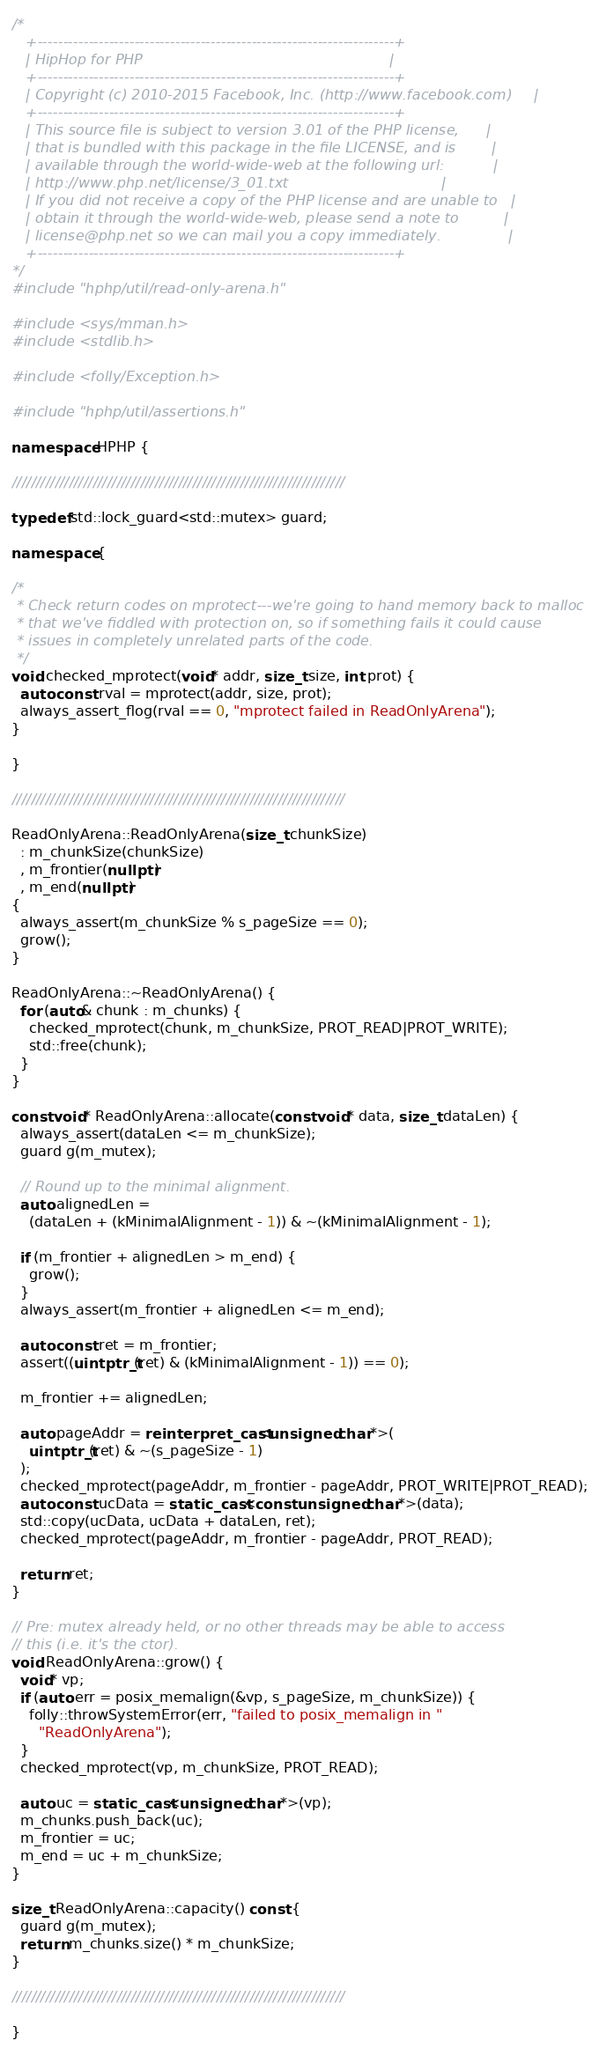<code> <loc_0><loc_0><loc_500><loc_500><_C++_>/*
   +----------------------------------------------------------------------+
   | HipHop for PHP                                                       |
   +----------------------------------------------------------------------+
   | Copyright (c) 2010-2015 Facebook, Inc. (http://www.facebook.com)     |
   +----------------------------------------------------------------------+
   | This source file is subject to version 3.01 of the PHP license,      |
   | that is bundled with this package in the file LICENSE, and is        |
   | available through the world-wide-web at the following url:           |
   | http://www.php.net/license/3_01.txt                                  |
   | If you did not receive a copy of the PHP license and are unable to   |
   | obtain it through the world-wide-web, please send a note to          |
   | license@php.net so we can mail you a copy immediately.               |
   +----------------------------------------------------------------------+
*/
#include "hphp/util/read-only-arena.h"

#include <sys/mman.h>
#include <stdlib.h>

#include <folly/Exception.h>

#include "hphp/util/assertions.h"

namespace HPHP {

//////////////////////////////////////////////////////////////////////

typedef std::lock_guard<std::mutex> guard;

namespace {

/*
 * Check return codes on mprotect---we're going to hand memory back to malloc
 * that we've fiddled with protection on, so if something fails it could cause
 * issues in completely unrelated parts of the code.
 */
void checked_mprotect(void* addr, size_t size, int prot) {
  auto const rval = mprotect(addr, size, prot);
  always_assert_flog(rval == 0, "mprotect failed in ReadOnlyArena");
}

}

//////////////////////////////////////////////////////////////////////

ReadOnlyArena::ReadOnlyArena(size_t chunkSize)
  : m_chunkSize(chunkSize)
  , m_frontier(nullptr)
  , m_end(nullptr)
{
  always_assert(m_chunkSize % s_pageSize == 0);
  grow();
}

ReadOnlyArena::~ReadOnlyArena() {
  for (auto& chunk : m_chunks) {
    checked_mprotect(chunk, m_chunkSize, PROT_READ|PROT_WRITE);
    std::free(chunk);
  }
}

const void* ReadOnlyArena::allocate(const void* data, size_t dataLen) {
  always_assert(dataLen <= m_chunkSize);
  guard g(m_mutex);

  // Round up to the minimal alignment.
  auto alignedLen =
    (dataLen + (kMinimalAlignment - 1)) & ~(kMinimalAlignment - 1);

  if (m_frontier + alignedLen > m_end) {
    grow();
  }
  always_assert(m_frontier + alignedLen <= m_end);

  auto const ret = m_frontier;
  assert((uintptr_t(ret) & (kMinimalAlignment - 1)) == 0);

  m_frontier += alignedLen;

  auto pageAddr = reinterpret_cast<unsigned char*>(
    uintptr_t(ret) & ~(s_pageSize - 1)
  );
  checked_mprotect(pageAddr, m_frontier - pageAddr, PROT_WRITE|PROT_READ);
  auto const ucData = static_cast<const unsigned char*>(data);
  std::copy(ucData, ucData + dataLen, ret);
  checked_mprotect(pageAddr, m_frontier - pageAddr, PROT_READ);

  return ret;
}

// Pre: mutex already held, or no other threads may be able to access
// this (i.e. it's the ctor).
void ReadOnlyArena::grow() {
  void* vp;
  if (auto err = posix_memalign(&vp, s_pageSize, m_chunkSize)) {
    folly::throwSystemError(err, "failed to posix_memalign in "
      "ReadOnlyArena");
  }
  checked_mprotect(vp, m_chunkSize, PROT_READ);

  auto uc = static_cast<unsigned char*>(vp);
  m_chunks.push_back(uc);
  m_frontier = uc;
  m_end = uc + m_chunkSize;
}

size_t ReadOnlyArena::capacity() const {
  guard g(m_mutex);
  return m_chunks.size() * m_chunkSize;
}

//////////////////////////////////////////////////////////////////////

}

</code> 